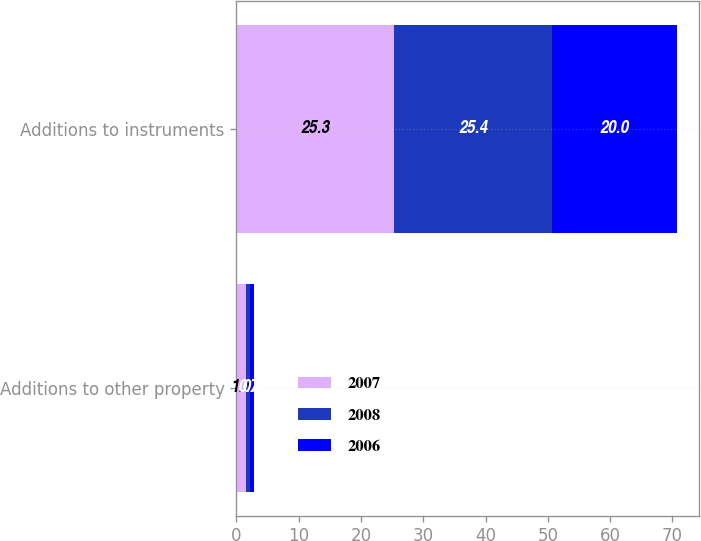Convert chart. <chart><loc_0><loc_0><loc_500><loc_500><stacked_bar_chart><ecel><fcel>Additions to other property<fcel>Additions to instruments<nl><fcel>2007<fcel>1.5<fcel>25.3<nl><fcel>2008<fcel>0.7<fcel>25.4<nl><fcel>2006<fcel>0.7<fcel>20<nl></chart> 